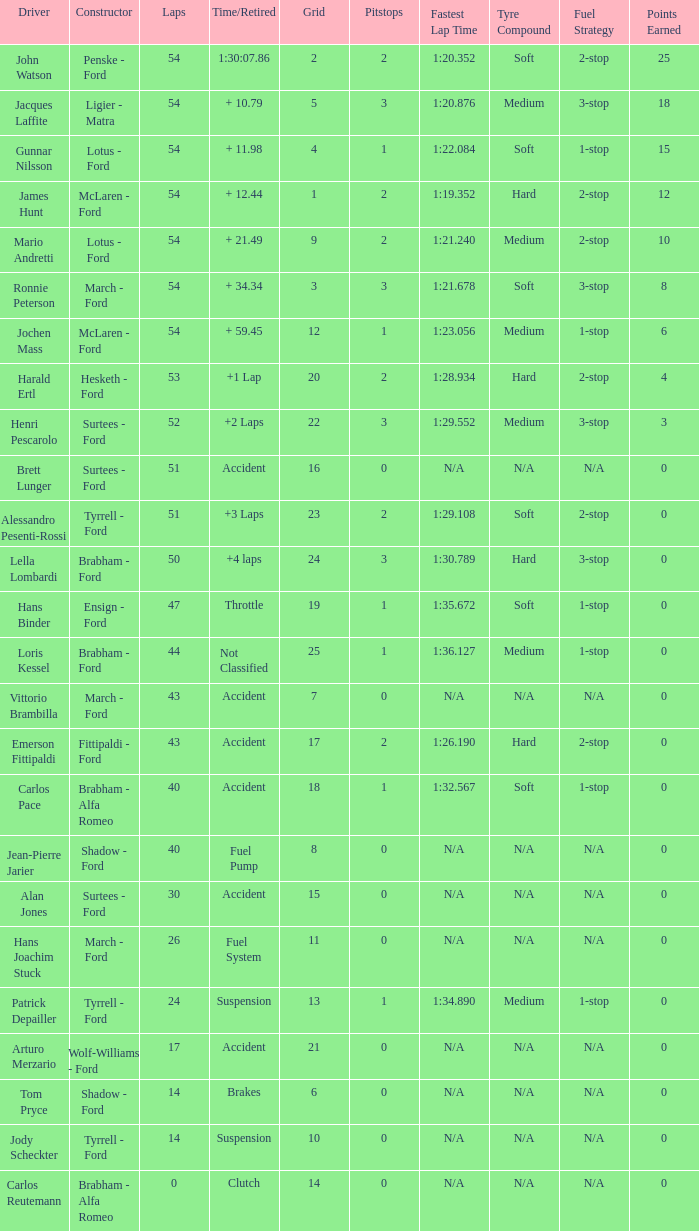How many laps did Emerson Fittipaldi do on a grid larger than 14, and when was the Time/Retired of accident? 1.0. Could you parse the entire table? {'header': ['Driver', 'Constructor', 'Laps', 'Time/Retired', 'Grid', 'Pitstops', 'Fastest Lap Time', 'Tyre Compound', 'Fuel Strategy', 'Points Earned'], 'rows': [['John Watson', 'Penske - Ford', '54', '1:30:07.86', '2', '2', '1:20.352', 'Soft', '2-stop', '25'], ['Jacques Laffite', 'Ligier - Matra', '54', '+ 10.79', '5', '3', '1:20.876', 'Medium', '3-stop', '18'], ['Gunnar Nilsson', 'Lotus - Ford', '54', '+ 11.98', '4', '1', '1:22.084', 'Soft', '1-stop', '15'], ['James Hunt', 'McLaren - Ford', '54', '+ 12.44', '1', '2', '1:19.352', 'Hard', '2-stop', '12'], ['Mario Andretti', 'Lotus - Ford', '54', '+ 21.49', '9', '2', '1:21.240', 'Medium', '2-stop', '10'], ['Ronnie Peterson', 'March - Ford', '54', '+ 34.34', '3', '3', '1:21.678', 'Soft', '3-stop', '8'], ['Jochen Mass', 'McLaren - Ford', '54', '+ 59.45', '12', '1', '1:23.056', 'Medium', '1-stop', '6'], ['Harald Ertl', 'Hesketh - Ford', '53', '+1 Lap', '20', '2', '1:28.934', 'Hard', '2-stop', '4'], ['Henri Pescarolo', 'Surtees - Ford', '52', '+2 Laps', '22', '3', '1:29.552', 'Medium', '3-stop', '3'], ['Brett Lunger', 'Surtees - Ford', '51', 'Accident', '16', '0', 'N/A', 'N/A', 'N/A', '0'], ['Alessandro Pesenti-Rossi', 'Tyrrell - Ford', '51', '+3 Laps', '23', '2', '1:29.108', 'Soft', '2-stop', '0'], ['Lella Lombardi', 'Brabham - Ford', '50', '+4 laps', '24', '3', '1:30.789', 'Hard', '3-stop', '0'], ['Hans Binder', 'Ensign - Ford', '47', 'Throttle', '19', '1', '1:35.672', 'Soft', '1-stop', '0'], ['Loris Kessel', 'Brabham - Ford', '44', 'Not Classified', '25', '1', '1:36.127', 'Medium', '1-stop', '0'], ['Vittorio Brambilla', 'March - Ford', '43', 'Accident', '7', '0', 'N/A', 'N/A', 'N/A', '0'], ['Emerson Fittipaldi', 'Fittipaldi - Ford', '43', 'Accident', '17', '2', '1:26.190', 'Hard', '2-stop', '0'], ['Carlos Pace', 'Brabham - Alfa Romeo', '40', 'Accident', '18', '1', '1:32.567', 'Soft', '1-stop', '0'], ['Jean-Pierre Jarier', 'Shadow - Ford', '40', 'Fuel Pump', '8', '0', 'N/A', 'N/A', 'N/A', '0'], ['Alan Jones', 'Surtees - Ford', '30', 'Accident', '15', '0', 'N/A', 'N/A', 'N/A', '0'], ['Hans Joachim Stuck', 'March - Ford', '26', 'Fuel System', '11', '0', 'N/A', 'N/A', 'N/A', '0'], ['Patrick Depailler', 'Tyrrell - Ford', '24', 'Suspension', '13', '1', '1:34.890', 'Medium', '1-stop', '0'], ['Arturo Merzario', 'Wolf-Williams - Ford', '17', 'Accident', '21', '0', 'N/A', 'N/A', 'N/A', '0'], ['Tom Pryce', 'Shadow - Ford', '14', 'Brakes', '6', '0', 'N/A', 'N/A', 'N/A', '0'], ['Jody Scheckter', 'Tyrrell - Ford', '14', 'Suspension', '10', '0', 'N/A', 'N/A', 'N/A', '0'], ['Carlos Reutemann', 'Brabham - Alfa Romeo', '0', 'Clutch', '14', '0', 'N/A', 'N/A', 'N/A', '0']]} 